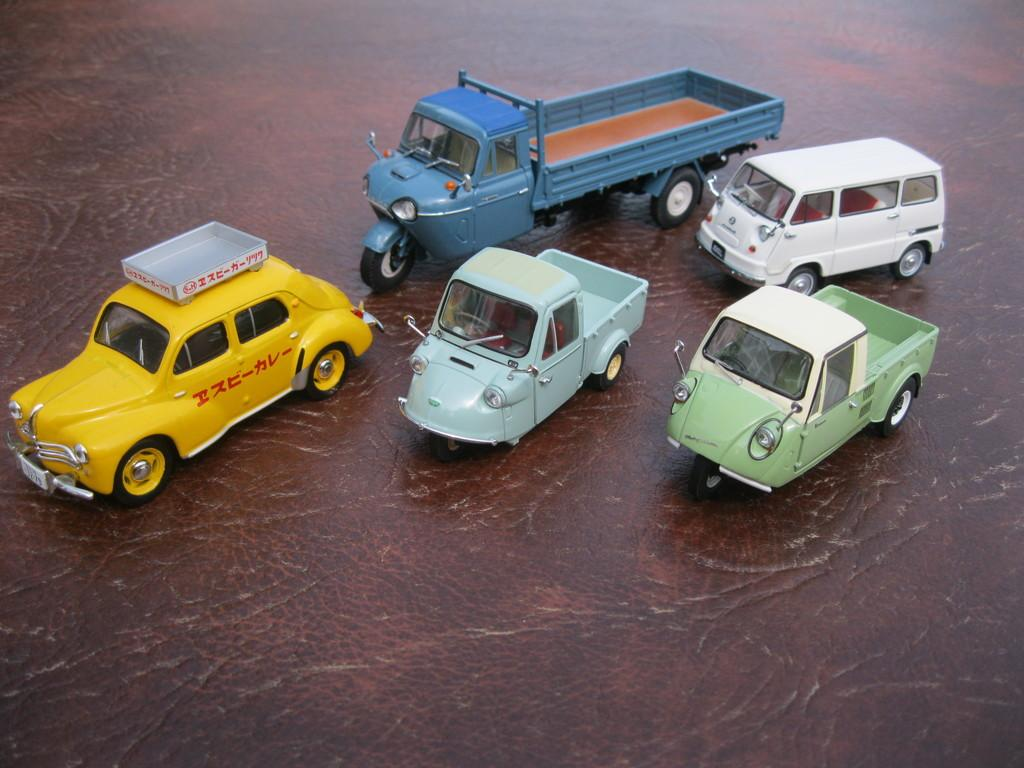<image>
Provide a brief description of the given image. A little yellow toy car with red foreign lettering on it sits on a table. 